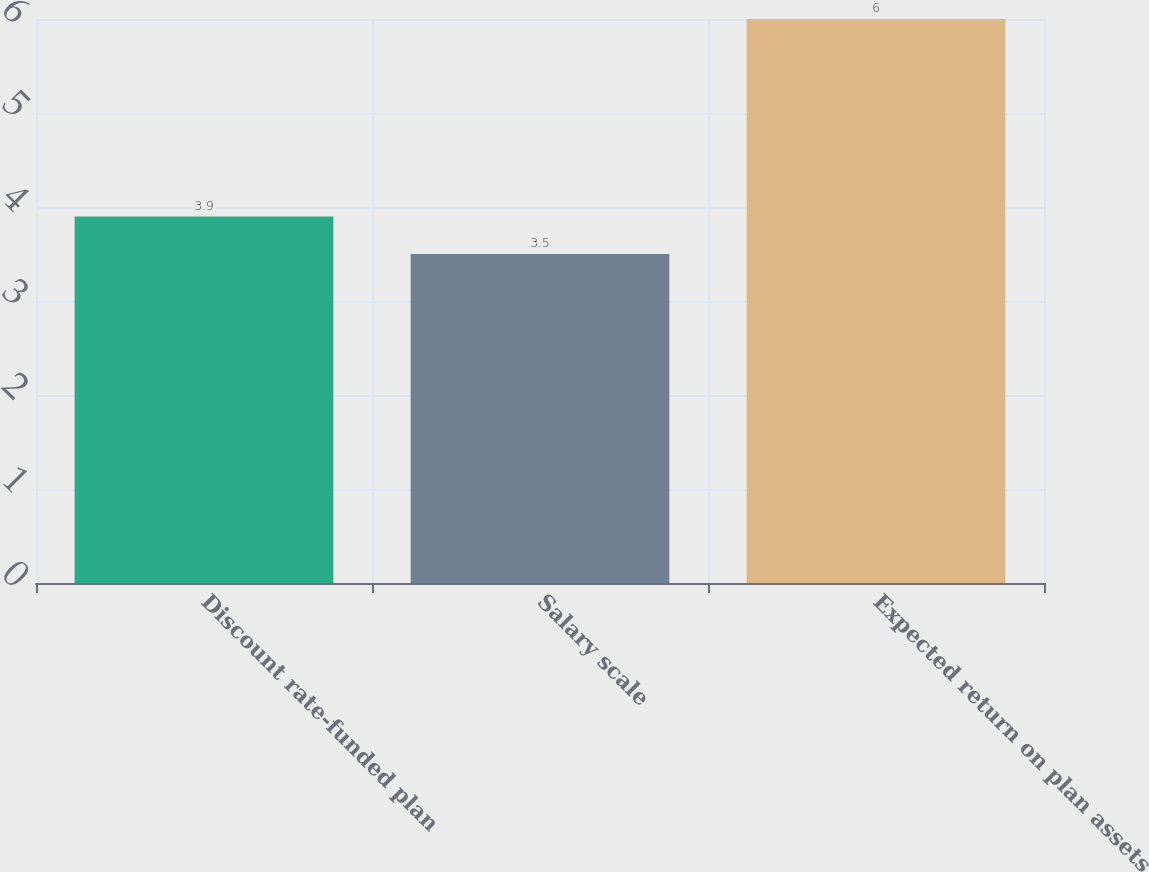Convert chart. <chart><loc_0><loc_0><loc_500><loc_500><bar_chart><fcel>Discount rate-funded plan<fcel>Salary scale<fcel>Expected return on plan assets<nl><fcel>3.9<fcel>3.5<fcel>6<nl></chart> 